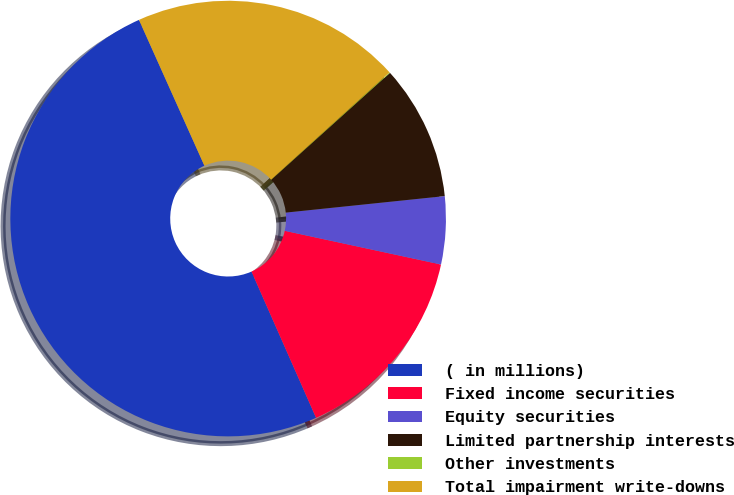Convert chart. <chart><loc_0><loc_0><loc_500><loc_500><pie_chart><fcel>( in millions)<fcel>Fixed income securities<fcel>Equity securities<fcel>Limited partnership interests<fcel>Other investments<fcel>Total impairment write-downs<nl><fcel>49.9%<fcel>15.0%<fcel>5.03%<fcel>10.02%<fcel>0.05%<fcel>19.99%<nl></chart> 